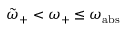<formula> <loc_0><loc_0><loc_500><loc_500>\tilde { \omega } _ { + } < \omega _ { + } \leq \omega _ { a b s }</formula> 